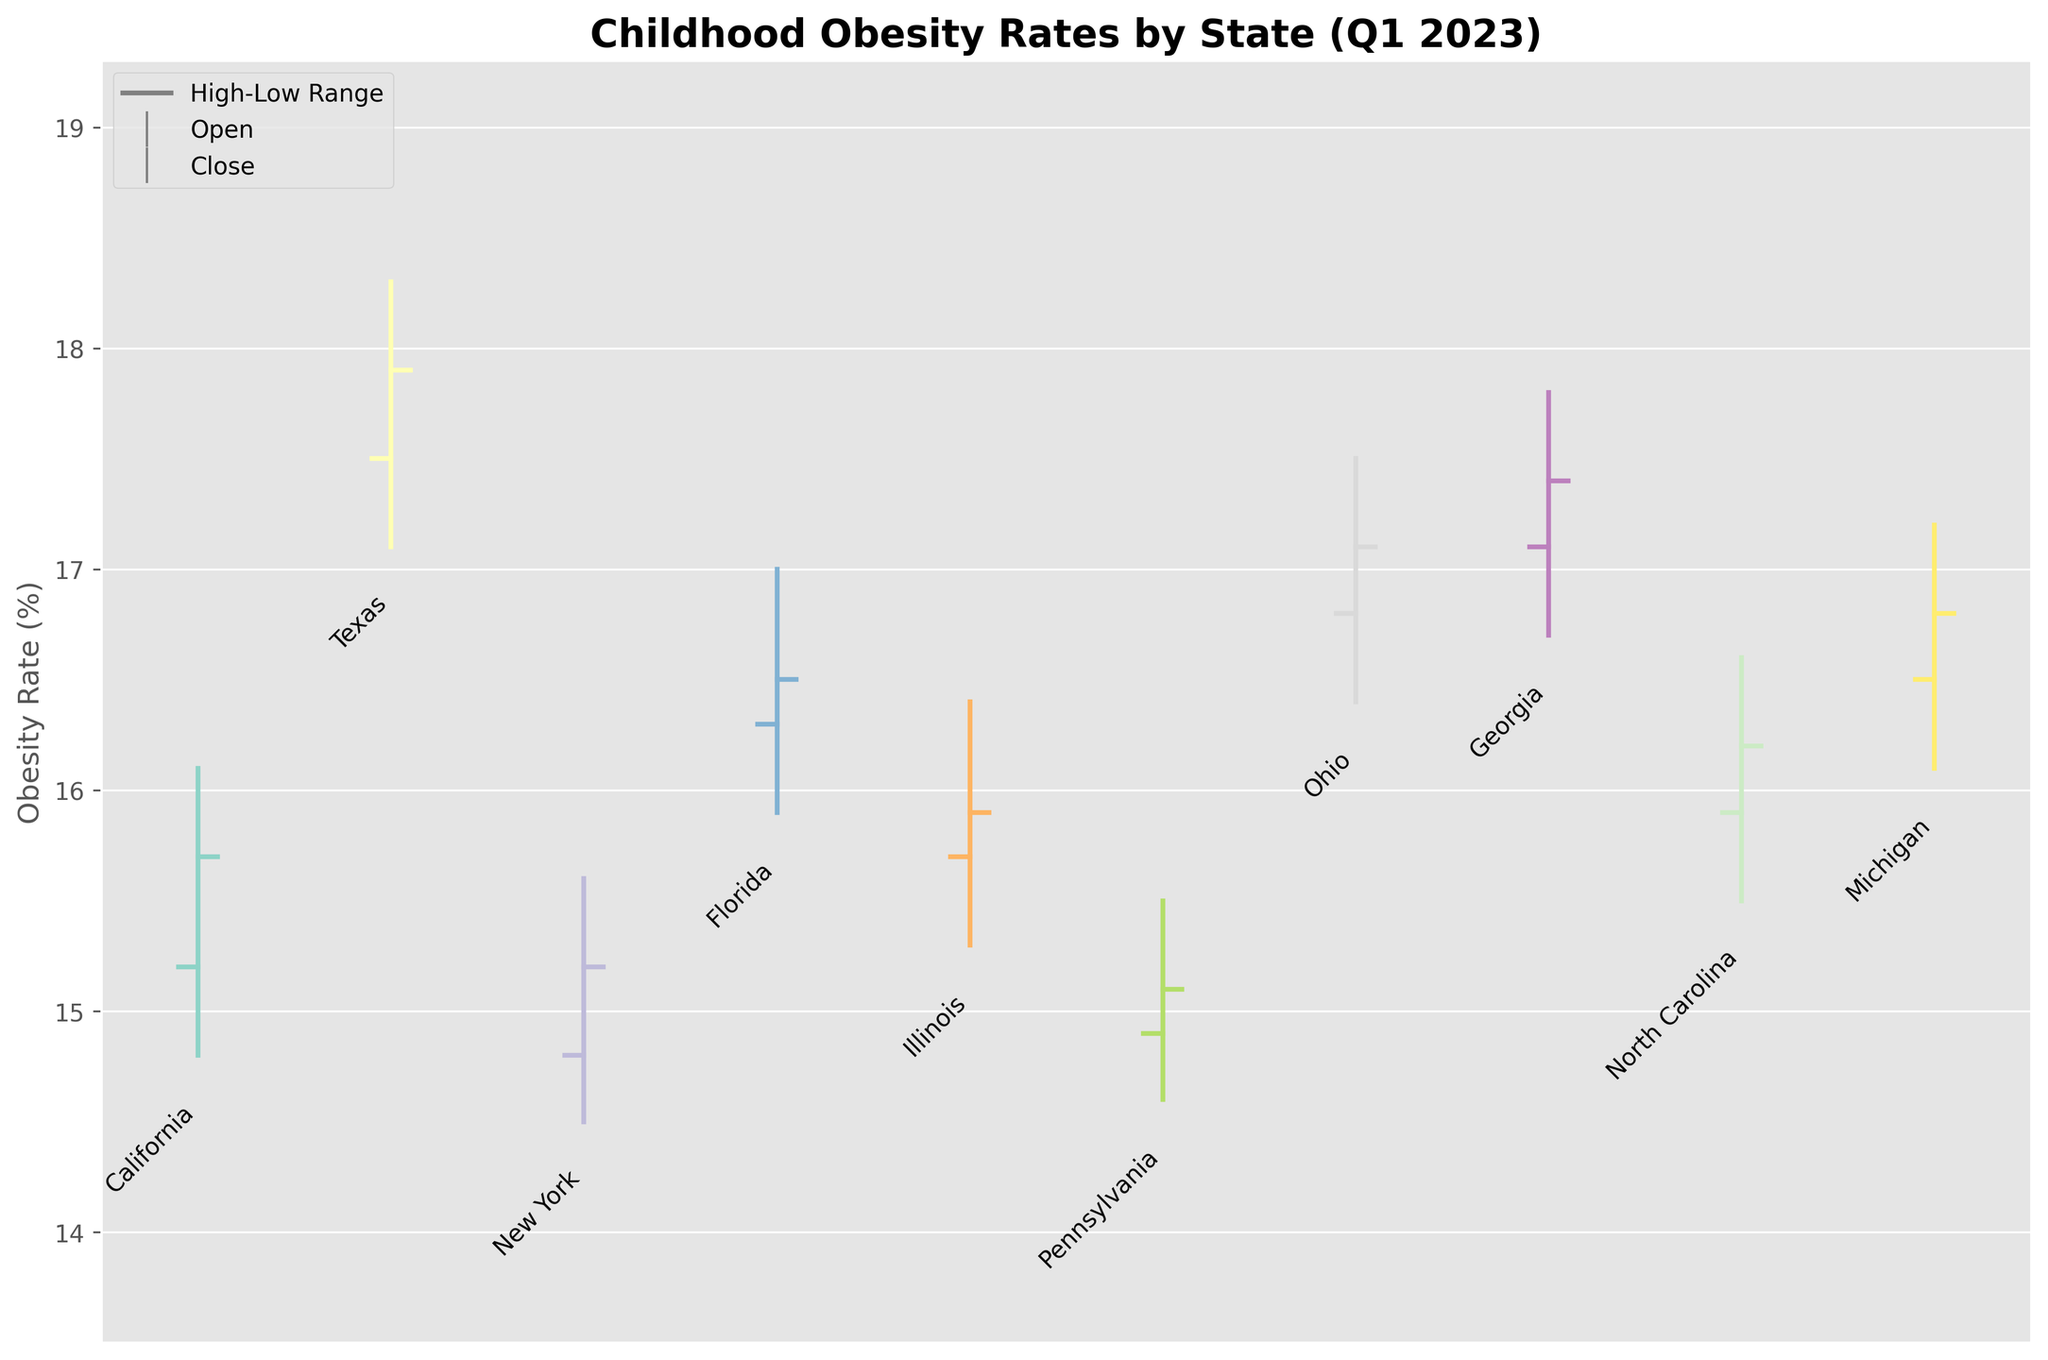Which state has the highest childhood obesity rate in Q1 2023? The highest childhood obesity rate can be identified by looking at the “High” values for each state in the OHLC chart. From the chart, Texas has the highest value which is 18.3%.
Answer: Texas What is the opening childhood obesity rate for California? The opening rate for California is represented by the left tick on the OHLC bar for California. According to the chart, this value is 15.2%.
Answer: 15.2% Which state shows the lowest closing childhood obesity rate in Q1 2023? The closing rate is represented by the right tick on the OHLC bar. By comparing the closing values for all states, Pennsylvania has the lowest closing rate at 15.1%.
Answer: Pennsylvania What is the difference between the high and low values for Ohio? Subtract the low value from the high value for Ohio. Ohio's high value is 17.5% and the low value is 16.4%. Thus, the difference is 17.5% - 16.4% = 1.1%.
Answer: 1.1% Which state had the smallest range between the highest and lowest childhood obesity rates? To determine the smallest range, look at the difference between the high and low values for each state. Pennsylvania has the smallest range with a high of 15.5% and a low of 14.6%, resulting in a range of 0.9%.
Answer: Pennsylvania Among California, Texas, and Florida, which state had the highest closing obesity rate? Compare the closing values of California, Texas, and Florida. California's closing rate is 15.7%, Texas is 17.9%, and Florida is 16.5%. Texas has the highest closing rate.
Answer: Texas What was the lowest obesity rate recorded for New York in Q1 2023? The lowest rate is represented by the bottom end of the OHLC bar for New York, which is 14.5%.
Answer: 14.5% How many states have a closing childhood obesity rate higher than 17%? By visually inspecting the closing values on the right tick of each OHLC bar, Texas (17.9%), Ohio (17.1%), and Georgia (17.4%) have closing rates higher than 17%. Thus, three states meet this criterion.
Answer: 3 For Michigan, what is the difference between the opening and closing childhood obesity rates? Subtract the opening rate from the closing rate for Michigan. Michigan's opening rate is 16.5% and closing rate is 16.8%. The difference is 16.8% - 16.5% = 0.3%.
Answer: 0.3% 